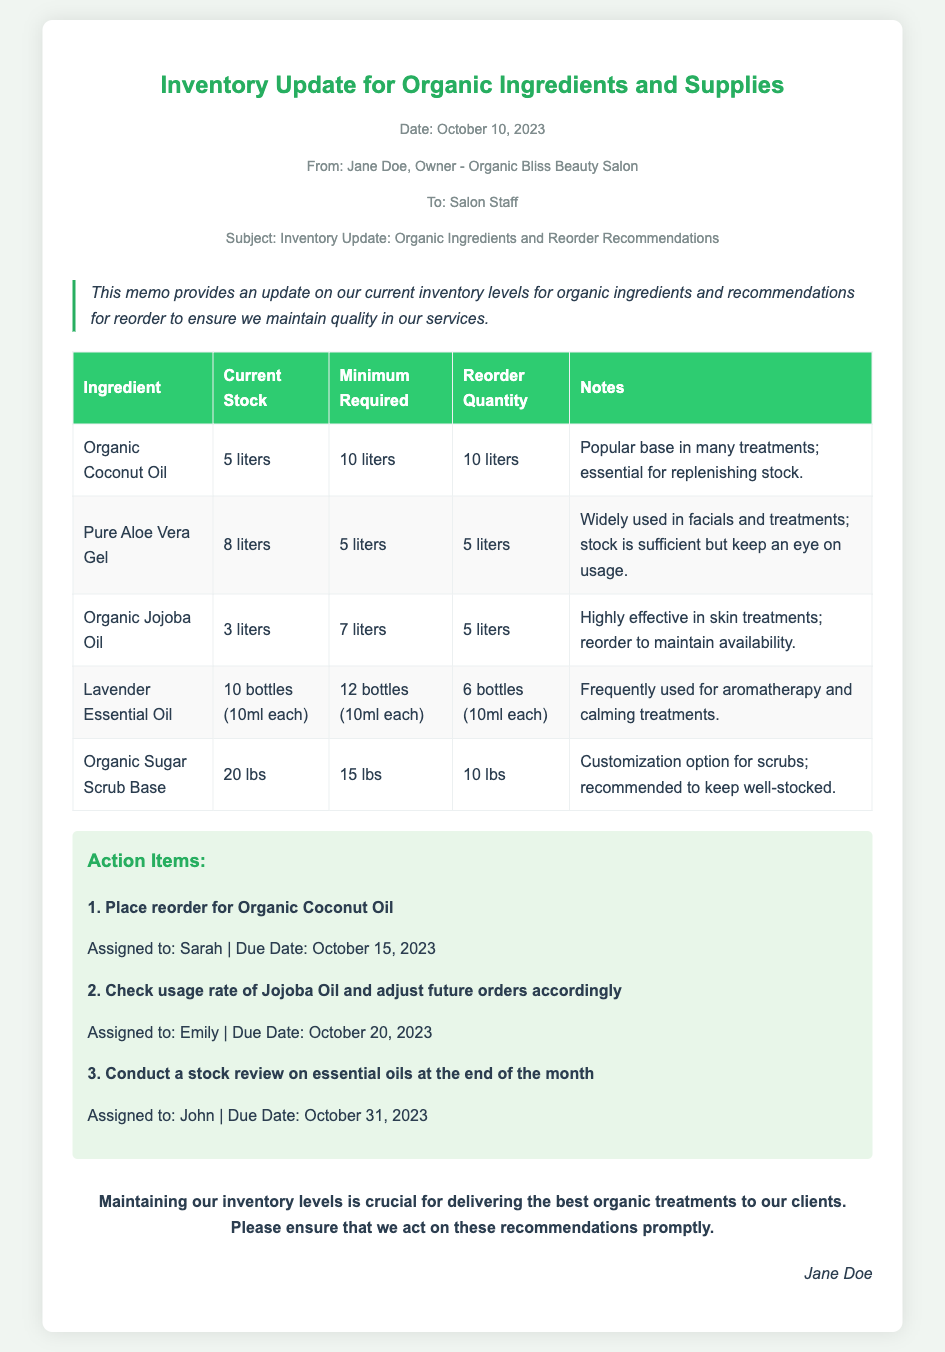What is the date of the memo? The date of the memo is stated in the meta-info section, which indicates October 10, 2023.
Answer: October 10, 2023 Who is the memo addressed to? The memo is addressed to the staff at Organic Bliss Beauty Salon, as mentioned in the meta-info section.
Answer: Salon Staff What is the current stock of Organic Jojoba Oil? The current stock is provided in the table, stating it has 3 liters.
Answer: 3 liters How much Organic Coconut Oil should be reordered? The reorder quantity is specified in the table for Organic Coconut Oil, which is 10 liters.
Answer: 10 liters Who is assigned to check the usage rate of Jojoba Oil? The action item regarding Jojoba Oil indicates that this task is assigned to Emily.
Answer: Emily Why is Lavender Essential Oil important? The notes section explains that Lavender Essential Oil is frequently used for aromatherapy and calming treatments.
Answer: Aromatherapy and calming treatments What is the minimum required stock level for Pure Aloe Vera Gel? The minimum required stock level can be found in the table, which indicates it is 5 liters.
Answer: 5 liters How many bottles of Lavender Essential Oil are currently in stock? The stock information provided in the table states there are 10 bottles of Lavender Essential Oil.
Answer: 10 bottles What action item is due on October 31, 2023? Review of essential oils is detailed in the action items, with a due date of October 31, 2023.
Answer: Conduct a stock review on essential oils 